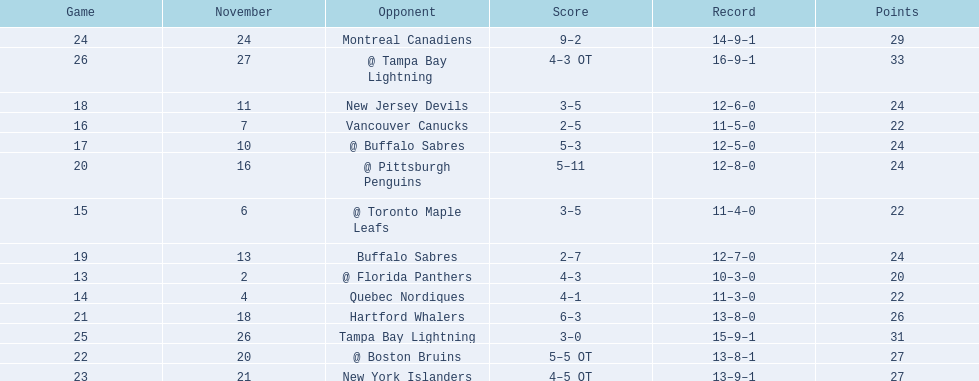What are the teams in the atlantic division? Quebec Nordiques, Vancouver Canucks, New Jersey Devils, Buffalo Sabres, Hartford Whalers, New York Islanders, Montreal Canadiens, Tampa Bay Lightning. Which of those scored fewer points than the philadelphia flyers? Tampa Bay Lightning. 